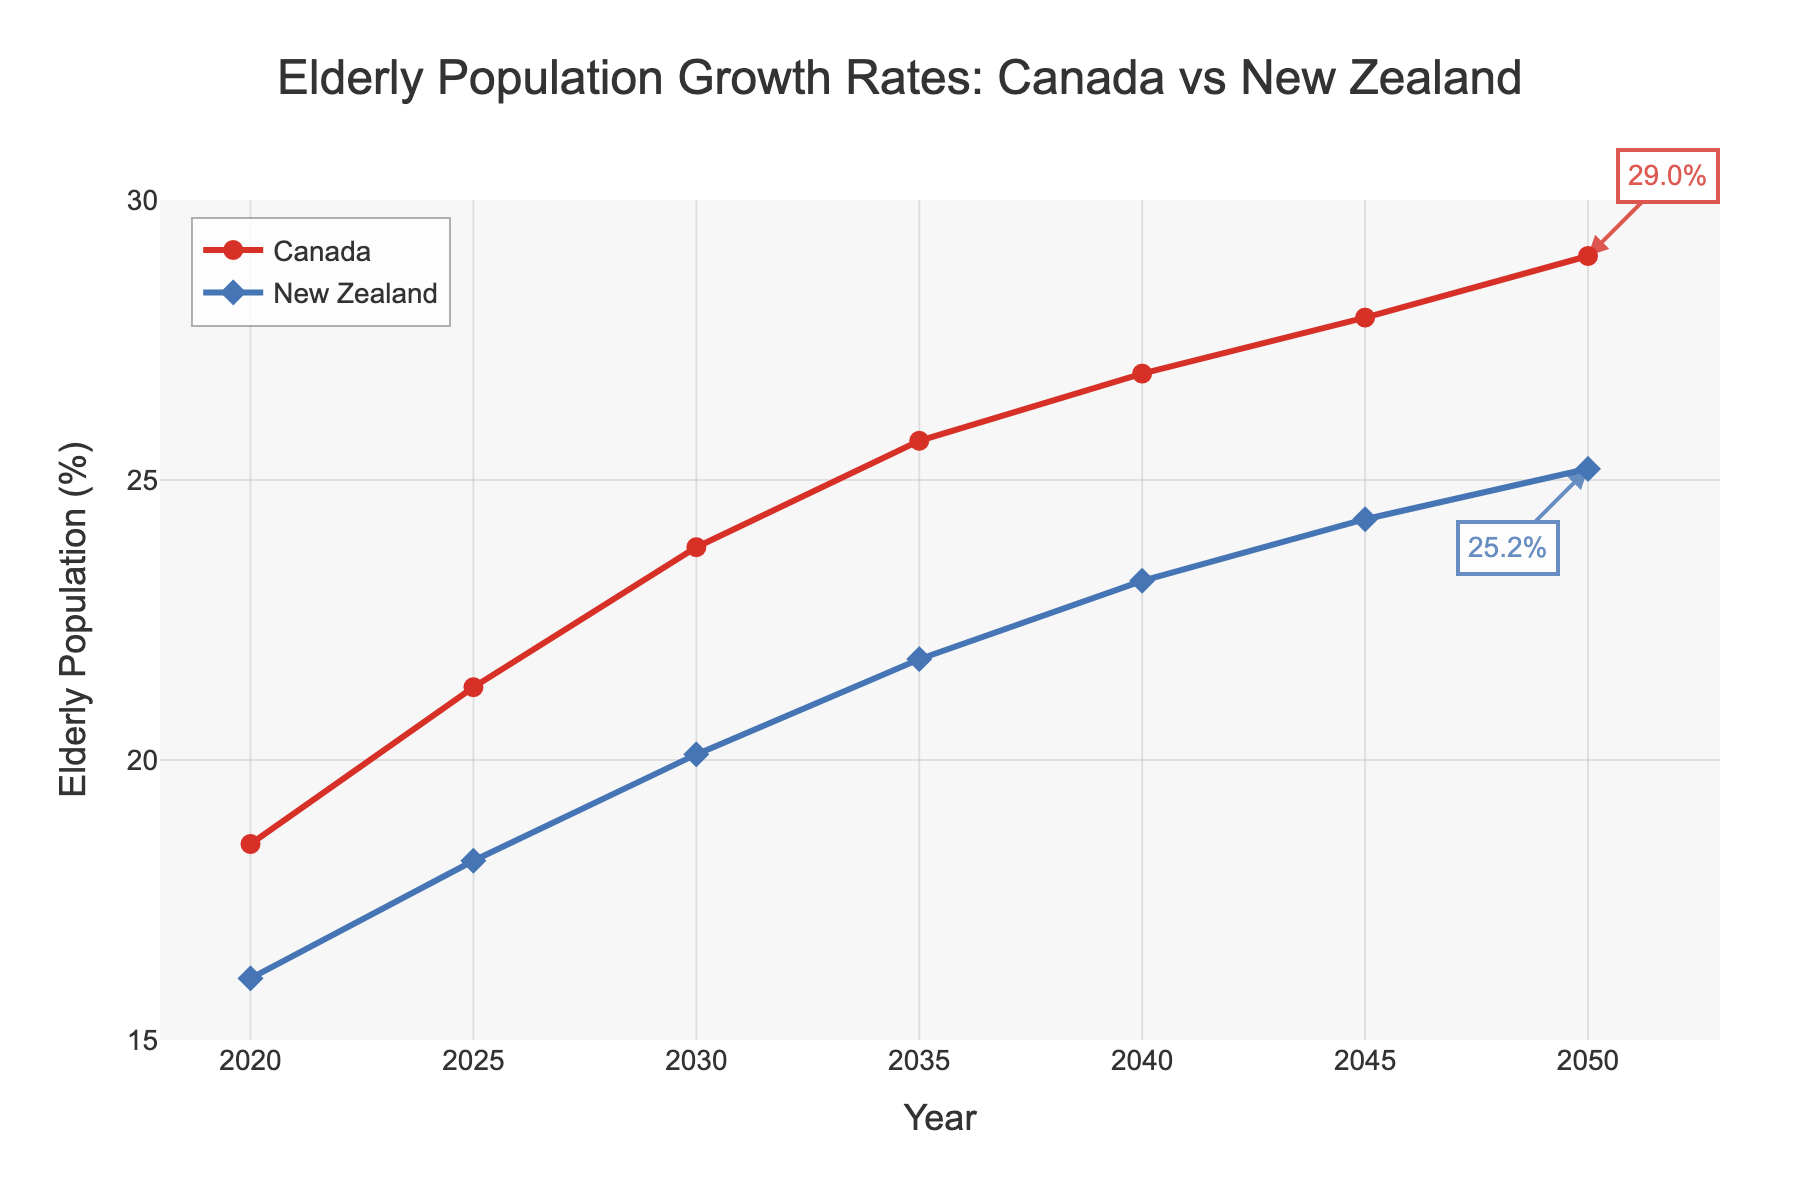What's the elderly population growth rate in Canada by 2050? To find the elderly population growth rate in Canada by 2050, refer to the end of the red line on the chart. The annotation indicates the percentage.
Answer: 29.0% How does the elderly population growth rate in New Zealand compare to Canada in 2025? Look at the points on the graph for the year 2025. The blue diamond represents New Zealand, and the red circle represents Canada. Compare the values.
Answer: New Zealand is 18.2%, Canada is 21.3% Which country has a higher growth rate in 2040, and by how much? Compare the values on both lines for the year 2040. Subtract the lower percentage from the higher percentage to find the difference.
Answer: Canada is higher by 3.7% What is the average elderly population percentage growth for New Zealand from 2020 to 2030? Add the values of New Zealand's elderly population for 2020, 2025, and 2030, then divide by the number of data points (3).
Answer: 18.1% What is the difference in elderly population growth between Canada and New Zealand in 2035? Identify the chart values for both countries in 2035. Subtract New Zealand's percentage from Canada's percentage.
Answer: 3.9% By how much does the elderly population percentage in New Zealand increase from 2020 to 2050? Subtract the value in 2020 from the value in 2050 for New Zealand's elderly population.
Answer: 9.1% Which country shows a faster predicted escalation in elderly population from 2025 to 2030? Calculate the increase for both countries from 2025 to 2030 by subtracting the 2025 value from the 2030 value. Compare both increases.
Answer: Canada How many percentage points does Canada’s elderly population increase from 2040 to 2050? Subtract the 2040 percentage from the 2050 percentage for Canada.
Answer: 2.1% What is the trend shown for New Zealand's elderly population from 2020 to 2050? Analyze the blue line representing New Zealand from 2020 to 2050.
Answer: An upward trend 